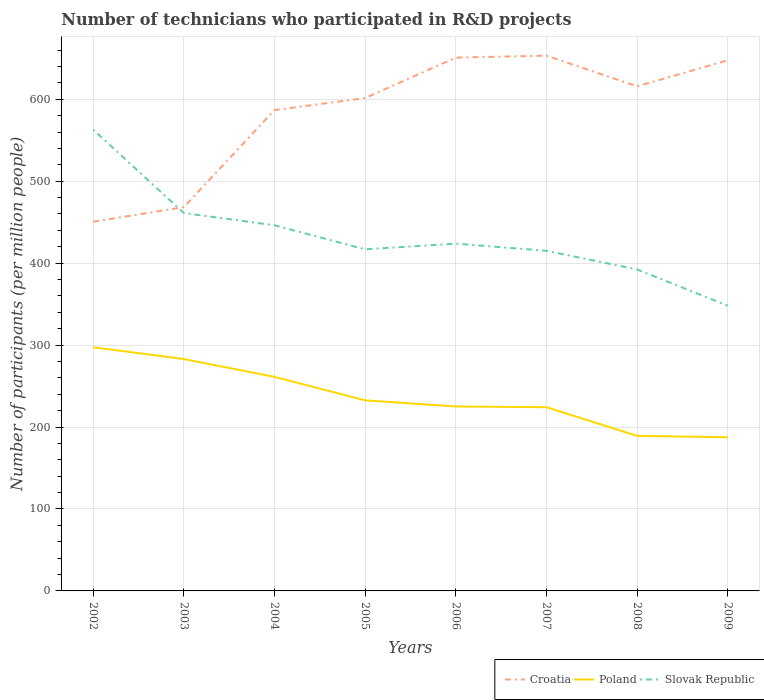How many different coloured lines are there?
Your answer should be compact. 3. Across all years, what is the maximum number of technicians who participated in R&D projects in Slovak Republic?
Make the answer very short. 348.06. What is the total number of technicians who participated in R&D projects in Slovak Republic in the graph?
Your response must be concise. 29.36. What is the difference between the highest and the second highest number of technicians who participated in R&D projects in Poland?
Ensure brevity in your answer.  109.86. Is the number of technicians who participated in R&D projects in Poland strictly greater than the number of technicians who participated in R&D projects in Slovak Republic over the years?
Keep it short and to the point. Yes. How many lines are there?
Make the answer very short. 3. How many years are there in the graph?
Provide a succinct answer. 8. What is the difference between two consecutive major ticks on the Y-axis?
Your answer should be compact. 100. Are the values on the major ticks of Y-axis written in scientific E-notation?
Offer a terse response. No. Does the graph contain grids?
Your answer should be compact. Yes. Where does the legend appear in the graph?
Your answer should be very brief. Bottom right. What is the title of the graph?
Ensure brevity in your answer.  Number of technicians who participated in R&D projects. What is the label or title of the Y-axis?
Make the answer very short. Number of participants (per million people). What is the Number of participants (per million people) in Croatia in 2002?
Offer a terse response. 450.56. What is the Number of participants (per million people) in Poland in 2002?
Your answer should be compact. 297.36. What is the Number of participants (per million people) in Slovak Republic in 2002?
Make the answer very short. 563. What is the Number of participants (per million people) of Croatia in 2003?
Your answer should be very brief. 468.31. What is the Number of participants (per million people) in Poland in 2003?
Offer a terse response. 282.98. What is the Number of participants (per million people) in Slovak Republic in 2003?
Your response must be concise. 461.14. What is the Number of participants (per million people) in Croatia in 2004?
Give a very brief answer. 586.77. What is the Number of participants (per million people) of Poland in 2004?
Provide a short and direct response. 261.19. What is the Number of participants (per million people) in Slovak Republic in 2004?
Offer a very short reply. 446.21. What is the Number of participants (per million people) in Croatia in 2005?
Keep it short and to the point. 601.41. What is the Number of participants (per million people) in Poland in 2005?
Your answer should be compact. 232.61. What is the Number of participants (per million people) in Slovak Republic in 2005?
Provide a short and direct response. 416.85. What is the Number of participants (per million people) of Croatia in 2006?
Your answer should be compact. 650.79. What is the Number of participants (per million people) in Poland in 2006?
Provide a short and direct response. 225.1. What is the Number of participants (per million people) in Slovak Republic in 2006?
Your answer should be very brief. 423.83. What is the Number of participants (per million people) of Croatia in 2007?
Your answer should be compact. 653.18. What is the Number of participants (per million people) of Poland in 2007?
Your response must be concise. 224.18. What is the Number of participants (per million people) of Slovak Republic in 2007?
Provide a succinct answer. 415.06. What is the Number of participants (per million people) in Croatia in 2008?
Your answer should be very brief. 615.77. What is the Number of participants (per million people) of Poland in 2008?
Keep it short and to the point. 189.22. What is the Number of participants (per million people) of Slovak Republic in 2008?
Offer a very short reply. 392.28. What is the Number of participants (per million people) of Croatia in 2009?
Make the answer very short. 647.52. What is the Number of participants (per million people) of Poland in 2009?
Keep it short and to the point. 187.5. What is the Number of participants (per million people) of Slovak Republic in 2009?
Offer a very short reply. 348.06. Across all years, what is the maximum Number of participants (per million people) in Croatia?
Give a very brief answer. 653.18. Across all years, what is the maximum Number of participants (per million people) of Poland?
Make the answer very short. 297.36. Across all years, what is the maximum Number of participants (per million people) of Slovak Republic?
Offer a very short reply. 563. Across all years, what is the minimum Number of participants (per million people) in Croatia?
Your response must be concise. 450.56. Across all years, what is the minimum Number of participants (per million people) of Poland?
Provide a succinct answer. 187.5. Across all years, what is the minimum Number of participants (per million people) of Slovak Republic?
Ensure brevity in your answer.  348.06. What is the total Number of participants (per million people) in Croatia in the graph?
Your answer should be compact. 4674.3. What is the total Number of participants (per million people) in Poland in the graph?
Offer a very short reply. 1900.15. What is the total Number of participants (per million people) of Slovak Republic in the graph?
Provide a short and direct response. 3466.42. What is the difference between the Number of participants (per million people) of Croatia in 2002 and that in 2003?
Your answer should be compact. -17.75. What is the difference between the Number of participants (per million people) of Poland in 2002 and that in 2003?
Ensure brevity in your answer.  14.38. What is the difference between the Number of participants (per million people) in Slovak Republic in 2002 and that in 2003?
Provide a short and direct response. 101.86. What is the difference between the Number of participants (per million people) in Croatia in 2002 and that in 2004?
Give a very brief answer. -136.21. What is the difference between the Number of participants (per million people) of Poland in 2002 and that in 2004?
Make the answer very short. 36.17. What is the difference between the Number of participants (per million people) in Slovak Republic in 2002 and that in 2004?
Offer a terse response. 116.79. What is the difference between the Number of participants (per million people) of Croatia in 2002 and that in 2005?
Make the answer very short. -150.85. What is the difference between the Number of participants (per million people) of Poland in 2002 and that in 2005?
Your answer should be very brief. 64.75. What is the difference between the Number of participants (per million people) in Slovak Republic in 2002 and that in 2005?
Provide a short and direct response. 146.15. What is the difference between the Number of participants (per million people) of Croatia in 2002 and that in 2006?
Offer a terse response. -200.23. What is the difference between the Number of participants (per million people) of Poland in 2002 and that in 2006?
Provide a short and direct response. 72.26. What is the difference between the Number of participants (per million people) of Slovak Republic in 2002 and that in 2006?
Ensure brevity in your answer.  139.16. What is the difference between the Number of participants (per million people) in Croatia in 2002 and that in 2007?
Provide a succinct answer. -202.63. What is the difference between the Number of participants (per million people) of Poland in 2002 and that in 2007?
Offer a terse response. 73.18. What is the difference between the Number of participants (per million people) in Slovak Republic in 2002 and that in 2007?
Offer a very short reply. 147.93. What is the difference between the Number of participants (per million people) of Croatia in 2002 and that in 2008?
Offer a terse response. -165.21. What is the difference between the Number of participants (per million people) of Poland in 2002 and that in 2008?
Your response must be concise. 108.14. What is the difference between the Number of participants (per million people) in Slovak Republic in 2002 and that in 2008?
Offer a terse response. 170.72. What is the difference between the Number of participants (per million people) in Croatia in 2002 and that in 2009?
Your answer should be compact. -196.96. What is the difference between the Number of participants (per million people) in Poland in 2002 and that in 2009?
Keep it short and to the point. 109.86. What is the difference between the Number of participants (per million people) of Slovak Republic in 2002 and that in 2009?
Provide a short and direct response. 214.94. What is the difference between the Number of participants (per million people) in Croatia in 2003 and that in 2004?
Offer a terse response. -118.46. What is the difference between the Number of participants (per million people) in Poland in 2003 and that in 2004?
Your answer should be compact. 21.79. What is the difference between the Number of participants (per million people) of Slovak Republic in 2003 and that in 2004?
Give a very brief answer. 14.93. What is the difference between the Number of participants (per million people) of Croatia in 2003 and that in 2005?
Ensure brevity in your answer.  -133.1. What is the difference between the Number of participants (per million people) in Poland in 2003 and that in 2005?
Offer a terse response. 50.37. What is the difference between the Number of participants (per million people) in Slovak Republic in 2003 and that in 2005?
Give a very brief answer. 44.29. What is the difference between the Number of participants (per million people) in Croatia in 2003 and that in 2006?
Offer a very short reply. -182.49. What is the difference between the Number of participants (per million people) in Poland in 2003 and that in 2006?
Provide a succinct answer. 57.88. What is the difference between the Number of participants (per million people) of Slovak Republic in 2003 and that in 2006?
Ensure brevity in your answer.  37.3. What is the difference between the Number of participants (per million people) in Croatia in 2003 and that in 2007?
Your answer should be compact. -184.88. What is the difference between the Number of participants (per million people) of Poland in 2003 and that in 2007?
Provide a short and direct response. 58.8. What is the difference between the Number of participants (per million people) of Slovak Republic in 2003 and that in 2007?
Your answer should be compact. 46.07. What is the difference between the Number of participants (per million people) of Croatia in 2003 and that in 2008?
Your answer should be very brief. -147.46. What is the difference between the Number of participants (per million people) of Poland in 2003 and that in 2008?
Your answer should be compact. 93.76. What is the difference between the Number of participants (per million people) of Slovak Republic in 2003 and that in 2008?
Keep it short and to the point. 68.86. What is the difference between the Number of participants (per million people) of Croatia in 2003 and that in 2009?
Your answer should be very brief. -179.21. What is the difference between the Number of participants (per million people) in Poland in 2003 and that in 2009?
Provide a succinct answer. 95.48. What is the difference between the Number of participants (per million people) in Slovak Republic in 2003 and that in 2009?
Offer a terse response. 113.08. What is the difference between the Number of participants (per million people) in Croatia in 2004 and that in 2005?
Keep it short and to the point. -14.64. What is the difference between the Number of participants (per million people) in Poland in 2004 and that in 2005?
Keep it short and to the point. 28.58. What is the difference between the Number of participants (per million people) in Slovak Republic in 2004 and that in 2005?
Your answer should be compact. 29.36. What is the difference between the Number of participants (per million people) of Croatia in 2004 and that in 2006?
Provide a succinct answer. -64.03. What is the difference between the Number of participants (per million people) of Poland in 2004 and that in 2006?
Your answer should be compact. 36.09. What is the difference between the Number of participants (per million people) in Slovak Republic in 2004 and that in 2006?
Ensure brevity in your answer.  22.38. What is the difference between the Number of participants (per million people) of Croatia in 2004 and that in 2007?
Keep it short and to the point. -66.42. What is the difference between the Number of participants (per million people) of Poland in 2004 and that in 2007?
Offer a terse response. 37.01. What is the difference between the Number of participants (per million people) in Slovak Republic in 2004 and that in 2007?
Offer a terse response. 31.15. What is the difference between the Number of participants (per million people) in Croatia in 2004 and that in 2008?
Your answer should be compact. -29. What is the difference between the Number of participants (per million people) in Poland in 2004 and that in 2008?
Make the answer very short. 71.97. What is the difference between the Number of participants (per million people) in Slovak Republic in 2004 and that in 2008?
Give a very brief answer. 53.93. What is the difference between the Number of participants (per million people) in Croatia in 2004 and that in 2009?
Your response must be concise. -60.75. What is the difference between the Number of participants (per million people) of Poland in 2004 and that in 2009?
Provide a short and direct response. 73.69. What is the difference between the Number of participants (per million people) of Slovak Republic in 2004 and that in 2009?
Give a very brief answer. 98.15. What is the difference between the Number of participants (per million people) of Croatia in 2005 and that in 2006?
Make the answer very short. -49.38. What is the difference between the Number of participants (per million people) in Poland in 2005 and that in 2006?
Provide a succinct answer. 7.51. What is the difference between the Number of participants (per million people) in Slovak Republic in 2005 and that in 2006?
Provide a succinct answer. -6.99. What is the difference between the Number of participants (per million people) in Croatia in 2005 and that in 2007?
Your answer should be very brief. -51.78. What is the difference between the Number of participants (per million people) in Poland in 2005 and that in 2007?
Ensure brevity in your answer.  8.43. What is the difference between the Number of participants (per million people) of Slovak Republic in 2005 and that in 2007?
Provide a succinct answer. 1.79. What is the difference between the Number of participants (per million people) in Croatia in 2005 and that in 2008?
Offer a terse response. -14.36. What is the difference between the Number of participants (per million people) of Poland in 2005 and that in 2008?
Make the answer very short. 43.39. What is the difference between the Number of participants (per million people) of Slovak Republic in 2005 and that in 2008?
Provide a succinct answer. 24.57. What is the difference between the Number of participants (per million people) in Croatia in 2005 and that in 2009?
Your response must be concise. -46.11. What is the difference between the Number of participants (per million people) in Poland in 2005 and that in 2009?
Keep it short and to the point. 45.11. What is the difference between the Number of participants (per million people) of Slovak Republic in 2005 and that in 2009?
Offer a very short reply. 68.79. What is the difference between the Number of participants (per million people) in Croatia in 2006 and that in 2007?
Offer a terse response. -2.39. What is the difference between the Number of participants (per million people) of Poland in 2006 and that in 2007?
Your answer should be compact. 0.92. What is the difference between the Number of participants (per million people) in Slovak Republic in 2006 and that in 2007?
Provide a short and direct response. 8.77. What is the difference between the Number of participants (per million people) of Croatia in 2006 and that in 2008?
Give a very brief answer. 35.02. What is the difference between the Number of participants (per million people) of Poland in 2006 and that in 2008?
Keep it short and to the point. 35.88. What is the difference between the Number of participants (per million people) of Slovak Republic in 2006 and that in 2008?
Make the answer very short. 31.56. What is the difference between the Number of participants (per million people) in Croatia in 2006 and that in 2009?
Ensure brevity in your answer.  3.28. What is the difference between the Number of participants (per million people) in Poland in 2006 and that in 2009?
Offer a very short reply. 37.6. What is the difference between the Number of participants (per million people) in Slovak Republic in 2006 and that in 2009?
Make the answer very short. 75.77. What is the difference between the Number of participants (per million people) in Croatia in 2007 and that in 2008?
Make the answer very short. 37.41. What is the difference between the Number of participants (per million people) in Poland in 2007 and that in 2008?
Provide a short and direct response. 34.96. What is the difference between the Number of participants (per million people) of Slovak Republic in 2007 and that in 2008?
Ensure brevity in your answer.  22.79. What is the difference between the Number of participants (per million people) in Croatia in 2007 and that in 2009?
Offer a very short reply. 5.67. What is the difference between the Number of participants (per million people) of Poland in 2007 and that in 2009?
Your response must be concise. 36.67. What is the difference between the Number of participants (per million people) in Slovak Republic in 2007 and that in 2009?
Your answer should be compact. 67. What is the difference between the Number of participants (per million people) in Croatia in 2008 and that in 2009?
Keep it short and to the point. -31.74. What is the difference between the Number of participants (per million people) in Poland in 2008 and that in 2009?
Keep it short and to the point. 1.72. What is the difference between the Number of participants (per million people) of Slovak Republic in 2008 and that in 2009?
Make the answer very short. 44.22. What is the difference between the Number of participants (per million people) in Croatia in 2002 and the Number of participants (per million people) in Poland in 2003?
Ensure brevity in your answer.  167.58. What is the difference between the Number of participants (per million people) of Croatia in 2002 and the Number of participants (per million people) of Slovak Republic in 2003?
Your answer should be compact. -10.58. What is the difference between the Number of participants (per million people) in Poland in 2002 and the Number of participants (per million people) in Slovak Republic in 2003?
Provide a short and direct response. -163.77. What is the difference between the Number of participants (per million people) of Croatia in 2002 and the Number of participants (per million people) of Poland in 2004?
Provide a short and direct response. 189.37. What is the difference between the Number of participants (per million people) of Croatia in 2002 and the Number of participants (per million people) of Slovak Republic in 2004?
Your answer should be very brief. 4.35. What is the difference between the Number of participants (per million people) of Poland in 2002 and the Number of participants (per million people) of Slovak Republic in 2004?
Your answer should be compact. -148.85. What is the difference between the Number of participants (per million people) in Croatia in 2002 and the Number of participants (per million people) in Poland in 2005?
Make the answer very short. 217.95. What is the difference between the Number of participants (per million people) of Croatia in 2002 and the Number of participants (per million people) of Slovak Republic in 2005?
Provide a short and direct response. 33.71. What is the difference between the Number of participants (per million people) of Poland in 2002 and the Number of participants (per million people) of Slovak Republic in 2005?
Offer a terse response. -119.48. What is the difference between the Number of participants (per million people) in Croatia in 2002 and the Number of participants (per million people) in Poland in 2006?
Your response must be concise. 225.46. What is the difference between the Number of participants (per million people) in Croatia in 2002 and the Number of participants (per million people) in Slovak Republic in 2006?
Offer a very short reply. 26.73. What is the difference between the Number of participants (per million people) in Poland in 2002 and the Number of participants (per million people) in Slovak Republic in 2006?
Offer a terse response. -126.47. What is the difference between the Number of participants (per million people) in Croatia in 2002 and the Number of participants (per million people) in Poland in 2007?
Ensure brevity in your answer.  226.38. What is the difference between the Number of participants (per million people) in Croatia in 2002 and the Number of participants (per million people) in Slovak Republic in 2007?
Provide a short and direct response. 35.5. What is the difference between the Number of participants (per million people) in Poland in 2002 and the Number of participants (per million people) in Slovak Republic in 2007?
Offer a very short reply. -117.7. What is the difference between the Number of participants (per million people) of Croatia in 2002 and the Number of participants (per million people) of Poland in 2008?
Your response must be concise. 261.34. What is the difference between the Number of participants (per million people) of Croatia in 2002 and the Number of participants (per million people) of Slovak Republic in 2008?
Provide a short and direct response. 58.28. What is the difference between the Number of participants (per million people) in Poland in 2002 and the Number of participants (per million people) in Slovak Republic in 2008?
Make the answer very short. -94.91. What is the difference between the Number of participants (per million people) in Croatia in 2002 and the Number of participants (per million people) in Poland in 2009?
Your answer should be compact. 263.06. What is the difference between the Number of participants (per million people) in Croatia in 2002 and the Number of participants (per million people) in Slovak Republic in 2009?
Provide a succinct answer. 102.5. What is the difference between the Number of participants (per million people) of Poland in 2002 and the Number of participants (per million people) of Slovak Republic in 2009?
Your answer should be compact. -50.7. What is the difference between the Number of participants (per million people) in Croatia in 2003 and the Number of participants (per million people) in Poland in 2004?
Give a very brief answer. 207.11. What is the difference between the Number of participants (per million people) in Croatia in 2003 and the Number of participants (per million people) in Slovak Republic in 2004?
Offer a terse response. 22.1. What is the difference between the Number of participants (per million people) in Poland in 2003 and the Number of participants (per million people) in Slovak Republic in 2004?
Offer a terse response. -163.23. What is the difference between the Number of participants (per million people) in Croatia in 2003 and the Number of participants (per million people) in Poland in 2005?
Your response must be concise. 235.7. What is the difference between the Number of participants (per million people) of Croatia in 2003 and the Number of participants (per million people) of Slovak Republic in 2005?
Give a very brief answer. 51.46. What is the difference between the Number of participants (per million people) of Poland in 2003 and the Number of participants (per million people) of Slovak Republic in 2005?
Make the answer very short. -133.86. What is the difference between the Number of participants (per million people) in Croatia in 2003 and the Number of participants (per million people) in Poland in 2006?
Ensure brevity in your answer.  243.21. What is the difference between the Number of participants (per million people) in Croatia in 2003 and the Number of participants (per million people) in Slovak Republic in 2006?
Provide a succinct answer. 44.47. What is the difference between the Number of participants (per million people) in Poland in 2003 and the Number of participants (per million people) in Slovak Republic in 2006?
Give a very brief answer. -140.85. What is the difference between the Number of participants (per million people) in Croatia in 2003 and the Number of participants (per million people) in Poland in 2007?
Your answer should be compact. 244.13. What is the difference between the Number of participants (per million people) of Croatia in 2003 and the Number of participants (per million people) of Slovak Republic in 2007?
Your response must be concise. 53.24. What is the difference between the Number of participants (per million people) in Poland in 2003 and the Number of participants (per million people) in Slovak Republic in 2007?
Provide a succinct answer. -132.08. What is the difference between the Number of participants (per million people) in Croatia in 2003 and the Number of participants (per million people) in Poland in 2008?
Your answer should be very brief. 279.08. What is the difference between the Number of participants (per million people) of Croatia in 2003 and the Number of participants (per million people) of Slovak Republic in 2008?
Provide a short and direct response. 76.03. What is the difference between the Number of participants (per million people) of Poland in 2003 and the Number of participants (per million people) of Slovak Republic in 2008?
Your response must be concise. -109.29. What is the difference between the Number of participants (per million people) in Croatia in 2003 and the Number of participants (per million people) in Poland in 2009?
Offer a terse response. 280.8. What is the difference between the Number of participants (per million people) of Croatia in 2003 and the Number of participants (per million people) of Slovak Republic in 2009?
Keep it short and to the point. 120.25. What is the difference between the Number of participants (per million people) of Poland in 2003 and the Number of participants (per million people) of Slovak Republic in 2009?
Offer a terse response. -65.08. What is the difference between the Number of participants (per million people) of Croatia in 2004 and the Number of participants (per million people) of Poland in 2005?
Your answer should be very brief. 354.16. What is the difference between the Number of participants (per million people) in Croatia in 2004 and the Number of participants (per million people) in Slovak Republic in 2005?
Keep it short and to the point. 169.92. What is the difference between the Number of participants (per million people) of Poland in 2004 and the Number of participants (per million people) of Slovak Republic in 2005?
Ensure brevity in your answer.  -155.66. What is the difference between the Number of participants (per million people) in Croatia in 2004 and the Number of participants (per million people) in Poland in 2006?
Offer a terse response. 361.67. What is the difference between the Number of participants (per million people) in Croatia in 2004 and the Number of participants (per million people) in Slovak Republic in 2006?
Keep it short and to the point. 162.93. What is the difference between the Number of participants (per million people) of Poland in 2004 and the Number of participants (per million people) of Slovak Republic in 2006?
Provide a succinct answer. -162.64. What is the difference between the Number of participants (per million people) of Croatia in 2004 and the Number of participants (per million people) of Poland in 2007?
Offer a very short reply. 362.59. What is the difference between the Number of participants (per million people) of Croatia in 2004 and the Number of participants (per million people) of Slovak Republic in 2007?
Your answer should be compact. 171.71. What is the difference between the Number of participants (per million people) of Poland in 2004 and the Number of participants (per million people) of Slovak Republic in 2007?
Ensure brevity in your answer.  -153.87. What is the difference between the Number of participants (per million people) of Croatia in 2004 and the Number of participants (per million people) of Poland in 2008?
Provide a short and direct response. 397.55. What is the difference between the Number of participants (per million people) of Croatia in 2004 and the Number of participants (per million people) of Slovak Republic in 2008?
Give a very brief answer. 194.49. What is the difference between the Number of participants (per million people) in Poland in 2004 and the Number of participants (per million people) in Slovak Republic in 2008?
Provide a succinct answer. -131.08. What is the difference between the Number of participants (per million people) in Croatia in 2004 and the Number of participants (per million people) in Poland in 2009?
Give a very brief answer. 399.26. What is the difference between the Number of participants (per million people) in Croatia in 2004 and the Number of participants (per million people) in Slovak Republic in 2009?
Keep it short and to the point. 238.71. What is the difference between the Number of participants (per million people) of Poland in 2004 and the Number of participants (per million people) of Slovak Republic in 2009?
Provide a succinct answer. -86.87. What is the difference between the Number of participants (per million people) in Croatia in 2005 and the Number of participants (per million people) in Poland in 2006?
Your answer should be very brief. 376.31. What is the difference between the Number of participants (per million people) in Croatia in 2005 and the Number of participants (per million people) in Slovak Republic in 2006?
Your response must be concise. 177.58. What is the difference between the Number of participants (per million people) of Poland in 2005 and the Number of participants (per million people) of Slovak Republic in 2006?
Give a very brief answer. -191.22. What is the difference between the Number of participants (per million people) of Croatia in 2005 and the Number of participants (per million people) of Poland in 2007?
Your answer should be very brief. 377.23. What is the difference between the Number of participants (per million people) in Croatia in 2005 and the Number of participants (per million people) in Slovak Republic in 2007?
Provide a succinct answer. 186.35. What is the difference between the Number of participants (per million people) in Poland in 2005 and the Number of participants (per million people) in Slovak Republic in 2007?
Ensure brevity in your answer.  -182.45. What is the difference between the Number of participants (per million people) in Croatia in 2005 and the Number of participants (per million people) in Poland in 2008?
Offer a terse response. 412.19. What is the difference between the Number of participants (per million people) in Croatia in 2005 and the Number of participants (per million people) in Slovak Republic in 2008?
Provide a succinct answer. 209.13. What is the difference between the Number of participants (per million people) of Poland in 2005 and the Number of participants (per million people) of Slovak Republic in 2008?
Offer a terse response. -159.67. What is the difference between the Number of participants (per million people) in Croatia in 2005 and the Number of participants (per million people) in Poland in 2009?
Ensure brevity in your answer.  413.91. What is the difference between the Number of participants (per million people) in Croatia in 2005 and the Number of participants (per million people) in Slovak Republic in 2009?
Make the answer very short. 253.35. What is the difference between the Number of participants (per million people) of Poland in 2005 and the Number of participants (per million people) of Slovak Republic in 2009?
Provide a succinct answer. -115.45. What is the difference between the Number of participants (per million people) of Croatia in 2006 and the Number of participants (per million people) of Poland in 2007?
Make the answer very short. 426.62. What is the difference between the Number of participants (per million people) in Croatia in 2006 and the Number of participants (per million people) in Slovak Republic in 2007?
Offer a terse response. 235.73. What is the difference between the Number of participants (per million people) of Poland in 2006 and the Number of participants (per million people) of Slovak Republic in 2007?
Ensure brevity in your answer.  -189.96. What is the difference between the Number of participants (per million people) of Croatia in 2006 and the Number of participants (per million people) of Poland in 2008?
Make the answer very short. 461.57. What is the difference between the Number of participants (per million people) in Croatia in 2006 and the Number of participants (per million people) in Slovak Republic in 2008?
Keep it short and to the point. 258.52. What is the difference between the Number of participants (per million people) of Poland in 2006 and the Number of participants (per million people) of Slovak Republic in 2008?
Give a very brief answer. -167.18. What is the difference between the Number of participants (per million people) in Croatia in 2006 and the Number of participants (per million people) in Poland in 2009?
Ensure brevity in your answer.  463.29. What is the difference between the Number of participants (per million people) of Croatia in 2006 and the Number of participants (per million people) of Slovak Republic in 2009?
Provide a short and direct response. 302.73. What is the difference between the Number of participants (per million people) of Poland in 2006 and the Number of participants (per million people) of Slovak Republic in 2009?
Provide a succinct answer. -122.96. What is the difference between the Number of participants (per million people) in Croatia in 2007 and the Number of participants (per million people) in Poland in 2008?
Keep it short and to the point. 463.96. What is the difference between the Number of participants (per million people) of Croatia in 2007 and the Number of participants (per million people) of Slovak Republic in 2008?
Ensure brevity in your answer.  260.91. What is the difference between the Number of participants (per million people) in Poland in 2007 and the Number of participants (per million people) in Slovak Republic in 2008?
Provide a short and direct response. -168.1. What is the difference between the Number of participants (per million people) of Croatia in 2007 and the Number of participants (per million people) of Poland in 2009?
Your answer should be compact. 465.68. What is the difference between the Number of participants (per million people) in Croatia in 2007 and the Number of participants (per million people) in Slovak Republic in 2009?
Your answer should be very brief. 305.13. What is the difference between the Number of participants (per million people) in Poland in 2007 and the Number of participants (per million people) in Slovak Republic in 2009?
Provide a succinct answer. -123.88. What is the difference between the Number of participants (per million people) of Croatia in 2008 and the Number of participants (per million people) of Poland in 2009?
Your response must be concise. 428.27. What is the difference between the Number of participants (per million people) in Croatia in 2008 and the Number of participants (per million people) in Slovak Republic in 2009?
Your answer should be very brief. 267.71. What is the difference between the Number of participants (per million people) of Poland in 2008 and the Number of participants (per million people) of Slovak Republic in 2009?
Provide a short and direct response. -158.84. What is the average Number of participants (per million people) of Croatia per year?
Your answer should be very brief. 584.29. What is the average Number of participants (per million people) of Poland per year?
Keep it short and to the point. 237.52. What is the average Number of participants (per million people) of Slovak Republic per year?
Ensure brevity in your answer.  433.3. In the year 2002, what is the difference between the Number of participants (per million people) in Croatia and Number of participants (per million people) in Poland?
Your answer should be compact. 153.2. In the year 2002, what is the difference between the Number of participants (per million people) of Croatia and Number of participants (per million people) of Slovak Republic?
Provide a short and direct response. -112.44. In the year 2002, what is the difference between the Number of participants (per million people) of Poland and Number of participants (per million people) of Slovak Republic?
Ensure brevity in your answer.  -265.63. In the year 2003, what is the difference between the Number of participants (per million people) in Croatia and Number of participants (per million people) in Poland?
Offer a very short reply. 185.32. In the year 2003, what is the difference between the Number of participants (per million people) in Croatia and Number of participants (per million people) in Slovak Republic?
Make the answer very short. 7.17. In the year 2003, what is the difference between the Number of participants (per million people) of Poland and Number of participants (per million people) of Slovak Republic?
Offer a very short reply. -178.15. In the year 2004, what is the difference between the Number of participants (per million people) in Croatia and Number of participants (per million people) in Poland?
Provide a succinct answer. 325.58. In the year 2004, what is the difference between the Number of participants (per million people) of Croatia and Number of participants (per million people) of Slovak Republic?
Your response must be concise. 140.56. In the year 2004, what is the difference between the Number of participants (per million people) in Poland and Number of participants (per million people) in Slovak Republic?
Give a very brief answer. -185.02. In the year 2005, what is the difference between the Number of participants (per million people) of Croatia and Number of participants (per million people) of Poland?
Offer a terse response. 368.8. In the year 2005, what is the difference between the Number of participants (per million people) in Croatia and Number of participants (per million people) in Slovak Republic?
Offer a terse response. 184.56. In the year 2005, what is the difference between the Number of participants (per million people) in Poland and Number of participants (per million people) in Slovak Republic?
Offer a very short reply. -184.24. In the year 2006, what is the difference between the Number of participants (per million people) in Croatia and Number of participants (per million people) in Poland?
Give a very brief answer. 425.69. In the year 2006, what is the difference between the Number of participants (per million people) in Croatia and Number of participants (per million people) in Slovak Republic?
Ensure brevity in your answer.  226.96. In the year 2006, what is the difference between the Number of participants (per million people) in Poland and Number of participants (per million people) in Slovak Republic?
Keep it short and to the point. -198.73. In the year 2007, what is the difference between the Number of participants (per million people) of Croatia and Number of participants (per million people) of Poland?
Your answer should be very brief. 429.01. In the year 2007, what is the difference between the Number of participants (per million people) of Croatia and Number of participants (per million people) of Slovak Republic?
Provide a short and direct response. 238.12. In the year 2007, what is the difference between the Number of participants (per million people) of Poland and Number of participants (per million people) of Slovak Republic?
Your answer should be very brief. -190.88. In the year 2008, what is the difference between the Number of participants (per million people) of Croatia and Number of participants (per million people) of Poland?
Your response must be concise. 426.55. In the year 2008, what is the difference between the Number of participants (per million people) of Croatia and Number of participants (per million people) of Slovak Republic?
Your answer should be very brief. 223.49. In the year 2008, what is the difference between the Number of participants (per million people) in Poland and Number of participants (per million people) in Slovak Republic?
Provide a short and direct response. -203.05. In the year 2009, what is the difference between the Number of participants (per million people) of Croatia and Number of participants (per million people) of Poland?
Your answer should be compact. 460.01. In the year 2009, what is the difference between the Number of participants (per million people) in Croatia and Number of participants (per million people) in Slovak Republic?
Offer a terse response. 299.46. In the year 2009, what is the difference between the Number of participants (per million people) of Poland and Number of participants (per million people) of Slovak Republic?
Keep it short and to the point. -160.56. What is the ratio of the Number of participants (per million people) in Croatia in 2002 to that in 2003?
Your response must be concise. 0.96. What is the ratio of the Number of participants (per million people) of Poland in 2002 to that in 2003?
Make the answer very short. 1.05. What is the ratio of the Number of participants (per million people) of Slovak Republic in 2002 to that in 2003?
Offer a very short reply. 1.22. What is the ratio of the Number of participants (per million people) in Croatia in 2002 to that in 2004?
Provide a succinct answer. 0.77. What is the ratio of the Number of participants (per million people) of Poland in 2002 to that in 2004?
Make the answer very short. 1.14. What is the ratio of the Number of participants (per million people) in Slovak Republic in 2002 to that in 2004?
Provide a succinct answer. 1.26. What is the ratio of the Number of participants (per million people) in Croatia in 2002 to that in 2005?
Provide a short and direct response. 0.75. What is the ratio of the Number of participants (per million people) in Poland in 2002 to that in 2005?
Offer a terse response. 1.28. What is the ratio of the Number of participants (per million people) of Slovak Republic in 2002 to that in 2005?
Your answer should be very brief. 1.35. What is the ratio of the Number of participants (per million people) of Croatia in 2002 to that in 2006?
Your answer should be very brief. 0.69. What is the ratio of the Number of participants (per million people) of Poland in 2002 to that in 2006?
Your response must be concise. 1.32. What is the ratio of the Number of participants (per million people) of Slovak Republic in 2002 to that in 2006?
Keep it short and to the point. 1.33. What is the ratio of the Number of participants (per million people) in Croatia in 2002 to that in 2007?
Give a very brief answer. 0.69. What is the ratio of the Number of participants (per million people) in Poland in 2002 to that in 2007?
Ensure brevity in your answer.  1.33. What is the ratio of the Number of participants (per million people) of Slovak Republic in 2002 to that in 2007?
Offer a terse response. 1.36. What is the ratio of the Number of participants (per million people) in Croatia in 2002 to that in 2008?
Offer a terse response. 0.73. What is the ratio of the Number of participants (per million people) in Poland in 2002 to that in 2008?
Your answer should be very brief. 1.57. What is the ratio of the Number of participants (per million people) in Slovak Republic in 2002 to that in 2008?
Provide a short and direct response. 1.44. What is the ratio of the Number of participants (per million people) of Croatia in 2002 to that in 2009?
Keep it short and to the point. 0.7. What is the ratio of the Number of participants (per million people) in Poland in 2002 to that in 2009?
Offer a very short reply. 1.59. What is the ratio of the Number of participants (per million people) of Slovak Republic in 2002 to that in 2009?
Your response must be concise. 1.62. What is the ratio of the Number of participants (per million people) of Croatia in 2003 to that in 2004?
Your answer should be compact. 0.8. What is the ratio of the Number of participants (per million people) of Poland in 2003 to that in 2004?
Your response must be concise. 1.08. What is the ratio of the Number of participants (per million people) in Slovak Republic in 2003 to that in 2004?
Offer a very short reply. 1.03. What is the ratio of the Number of participants (per million people) of Croatia in 2003 to that in 2005?
Give a very brief answer. 0.78. What is the ratio of the Number of participants (per million people) of Poland in 2003 to that in 2005?
Ensure brevity in your answer.  1.22. What is the ratio of the Number of participants (per million people) in Slovak Republic in 2003 to that in 2005?
Your answer should be very brief. 1.11. What is the ratio of the Number of participants (per million people) of Croatia in 2003 to that in 2006?
Offer a terse response. 0.72. What is the ratio of the Number of participants (per million people) in Poland in 2003 to that in 2006?
Your answer should be compact. 1.26. What is the ratio of the Number of participants (per million people) in Slovak Republic in 2003 to that in 2006?
Keep it short and to the point. 1.09. What is the ratio of the Number of participants (per million people) of Croatia in 2003 to that in 2007?
Keep it short and to the point. 0.72. What is the ratio of the Number of participants (per million people) in Poland in 2003 to that in 2007?
Keep it short and to the point. 1.26. What is the ratio of the Number of participants (per million people) in Slovak Republic in 2003 to that in 2007?
Make the answer very short. 1.11. What is the ratio of the Number of participants (per million people) in Croatia in 2003 to that in 2008?
Offer a terse response. 0.76. What is the ratio of the Number of participants (per million people) in Poland in 2003 to that in 2008?
Offer a very short reply. 1.5. What is the ratio of the Number of participants (per million people) in Slovak Republic in 2003 to that in 2008?
Your response must be concise. 1.18. What is the ratio of the Number of participants (per million people) of Croatia in 2003 to that in 2009?
Offer a very short reply. 0.72. What is the ratio of the Number of participants (per million people) of Poland in 2003 to that in 2009?
Provide a short and direct response. 1.51. What is the ratio of the Number of participants (per million people) of Slovak Republic in 2003 to that in 2009?
Your response must be concise. 1.32. What is the ratio of the Number of participants (per million people) of Croatia in 2004 to that in 2005?
Ensure brevity in your answer.  0.98. What is the ratio of the Number of participants (per million people) of Poland in 2004 to that in 2005?
Provide a short and direct response. 1.12. What is the ratio of the Number of participants (per million people) of Slovak Republic in 2004 to that in 2005?
Make the answer very short. 1.07. What is the ratio of the Number of participants (per million people) in Croatia in 2004 to that in 2006?
Keep it short and to the point. 0.9. What is the ratio of the Number of participants (per million people) in Poland in 2004 to that in 2006?
Provide a succinct answer. 1.16. What is the ratio of the Number of participants (per million people) in Slovak Republic in 2004 to that in 2006?
Provide a short and direct response. 1.05. What is the ratio of the Number of participants (per million people) in Croatia in 2004 to that in 2007?
Offer a very short reply. 0.9. What is the ratio of the Number of participants (per million people) of Poland in 2004 to that in 2007?
Provide a short and direct response. 1.17. What is the ratio of the Number of participants (per million people) in Slovak Republic in 2004 to that in 2007?
Provide a succinct answer. 1.07. What is the ratio of the Number of participants (per million people) in Croatia in 2004 to that in 2008?
Keep it short and to the point. 0.95. What is the ratio of the Number of participants (per million people) in Poland in 2004 to that in 2008?
Offer a terse response. 1.38. What is the ratio of the Number of participants (per million people) in Slovak Republic in 2004 to that in 2008?
Your answer should be very brief. 1.14. What is the ratio of the Number of participants (per million people) in Croatia in 2004 to that in 2009?
Your answer should be very brief. 0.91. What is the ratio of the Number of participants (per million people) of Poland in 2004 to that in 2009?
Make the answer very short. 1.39. What is the ratio of the Number of participants (per million people) in Slovak Republic in 2004 to that in 2009?
Your answer should be very brief. 1.28. What is the ratio of the Number of participants (per million people) of Croatia in 2005 to that in 2006?
Keep it short and to the point. 0.92. What is the ratio of the Number of participants (per million people) of Poland in 2005 to that in 2006?
Provide a succinct answer. 1.03. What is the ratio of the Number of participants (per million people) in Slovak Republic in 2005 to that in 2006?
Keep it short and to the point. 0.98. What is the ratio of the Number of participants (per million people) in Croatia in 2005 to that in 2007?
Offer a very short reply. 0.92. What is the ratio of the Number of participants (per million people) in Poland in 2005 to that in 2007?
Ensure brevity in your answer.  1.04. What is the ratio of the Number of participants (per million people) in Croatia in 2005 to that in 2008?
Keep it short and to the point. 0.98. What is the ratio of the Number of participants (per million people) in Poland in 2005 to that in 2008?
Your response must be concise. 1.23. What is the ratio of the Number of participants (per million people) in Slovak Republic in 2005 to that in 2008?
Provide a short and direct response. 1.06. What is the ratio of the Number of participants (per million people) of Croatia in 2005 to that in 2009?
Your answer should be compact. 0.93. What is the ratio of the Number of participants (per million people) in Poland in 2005 to that in 2009?
Offer a terse response. 1.24. What is the ratio of the Number of participants (per million people) in Slovak Republic in 2005 to that in 2009?
Offer a terse response. 1.2. What is the ratio of the Number of participants (per million people) in Poland in 2006 to that in 2007?
Provide a succinct answer. 1. What is the ratio of the Number of participants (per million people) of Slovak Republic in 2006 to that in 2007?
Keep it short and to the point. 1.02. What is the ratio of the Number of participants (per million people) of Croatia in 2006 to that in 2008?
Keep it short and to the point. 1.06. What is the ratio of the Number of participants (per million people) of Poland in 2006 to that in 2008?
Your answer should be compact. 1.19. What is the ratio of the Number of participants (per million people) in Slovak Republic in 2006 to that in 2008?
Your answer should be very brief. 1.08. What is the ratio of the Number of participants (per million people) in Croatia in 2006 to that in 2009?
Keep it short and to the point. 1.01. What is the ratio of the Number of participants (per million people) of Poland in 2006 to that in 2009?
Offer a very short reply. 1.2. What is the ratio of the Number of participants (per million people) of Slovak Republic in 2006 to that in 2009?
Keep it short and to the point. 1.22. What is the ratio of the Number of participants (per million people) in Croatia in 2007 to that in 2008?
Make the answer very short. 1.06. What is the ratio of the Number of participants (per million people) of Poland in 2007 to that in 2008?
Ensure brevity in your answer.  1.18. What is the ratio of the Number of participants (per million people) of Slovak Republic in 2007 to that in 2008?
Provide a short and direct response. 1.06. What is the ratio of the Number of participants (per million people) in Croatia in 2007 to that in 2009?
Keep it short and to the point. 1.01. What is the ratio of the Number of participants (per million people) in Poland in 2007 to that in 2009?
Ensure brevity in your answer.  1.2. What is the ratio of the Number of participants (per million people) of Slovak Republic in 2007 to that in 2009?
Your answer should be very brief. 1.19. What is the ratio of the Number of participants (per million people) of Croatia in 2008 to that in 2009?
Keep it short and to the point. 0.95. What is the ratio of the Number of participants (per million people) of Poland in 2008 to that in 2009?
Provide a succinct answer. 1.01. What is the ratio of the Number of participants (per million people) of Slovak Republic in 2008 to that in 2009?
Keep it short and to the point. 1.13. What is the difference between the highest and the second highest Number of participants (per million people) of Croatia?
Your response must be concise. 2.39. What is the difference between the highest and the second highest Number of participants (per million people) in Poland?
Your response must be concise. 14.38. What is the difference between the highest and the second highest Number of participants (per million people) in Slovak Republic?
Provide a short and direct response. 101.86. What is the difference between the highest and the lowest Number of participants (per million people) of Croatia?
Give a very brief answer. 202.63. What is the difference between the highest and the lowest Number of participants (per million people) in Poland?
Your response must be concise. 109.86. What is the difference between the highest and the lowest Number of participants (per million people) in Slovak Republic?
Offer a very short reply. 214.94. 